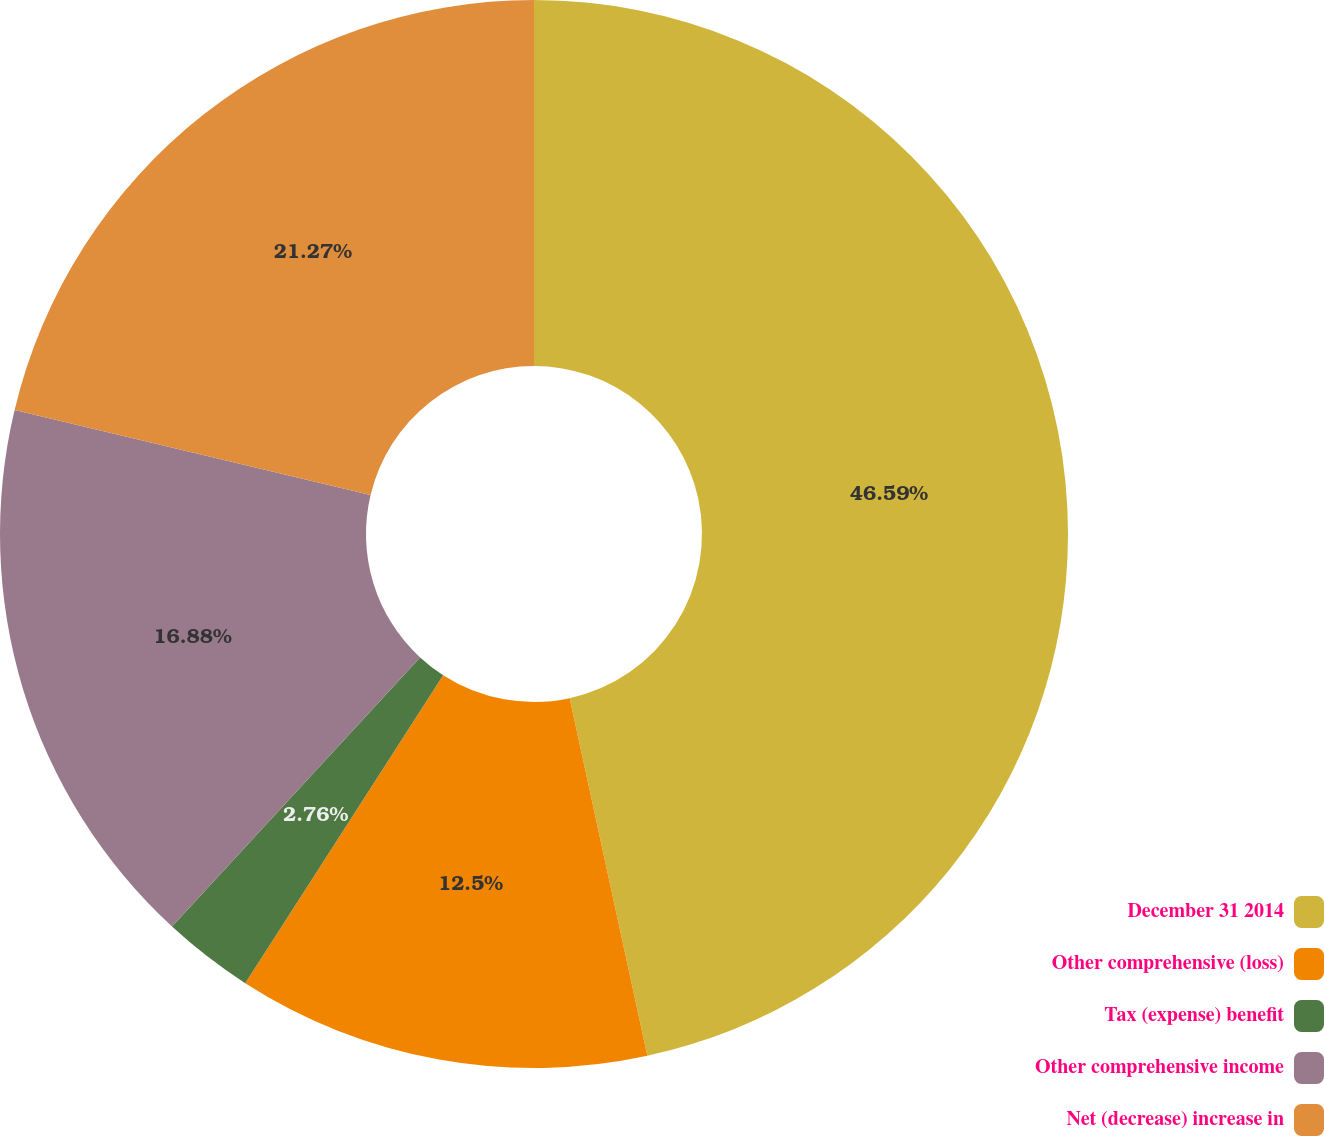Convert chart. <chart><loc_0><loc_0><loc_500><loc_500><pie_chart><fcel>December 31 2014<fcel>Other comprehensive (loss)<fcel>Tax (expense) benefit<fcel>Other comprehensive income<fcel>Net (decrease) increase in<nl><fcel>46.6%<fcel>12.5%<fcel>2.76%<fcel>16.88%<fcel>21.27%<nl></chart> 